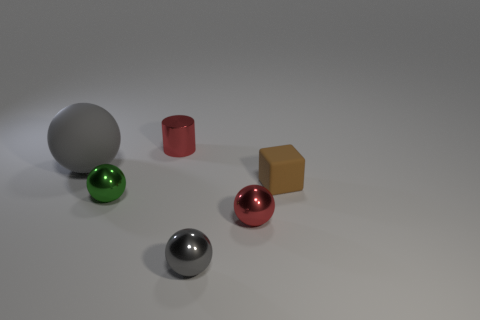Subtract all tiny green balls. How many balls are left? 3 Add 3 big brown cylinders. How many objects exist? 9 Subtract all red cylinders. How many gray balls are left? 2 Subtract all red spheres. How many spheres are left? 3 Subtract all balls. How many objects are left? 2 Subtract all big metal cubes. Subtract all tiny metallic balls. How many objects are left? 3 Add 1 tiny red cylinders. How many tiny red cylinders are left? 2 Add 4 small objects. How many small objects exist? 9 Subtract 0 cyan balls. How many objects are left? 6 Subtract 1 cylinders. How many cylinders are left? 0 